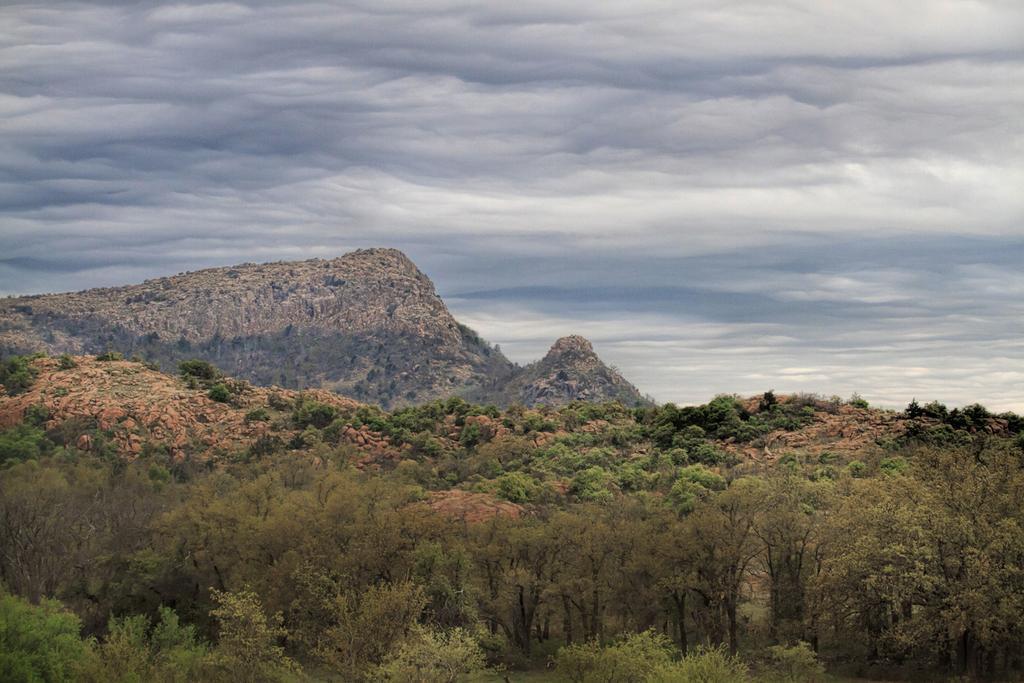Can you describe this image briefly? In this picture there is greenery at the bottom side of the image and there is sky at the top side of the image, there is a mountain on the left side of the image. 